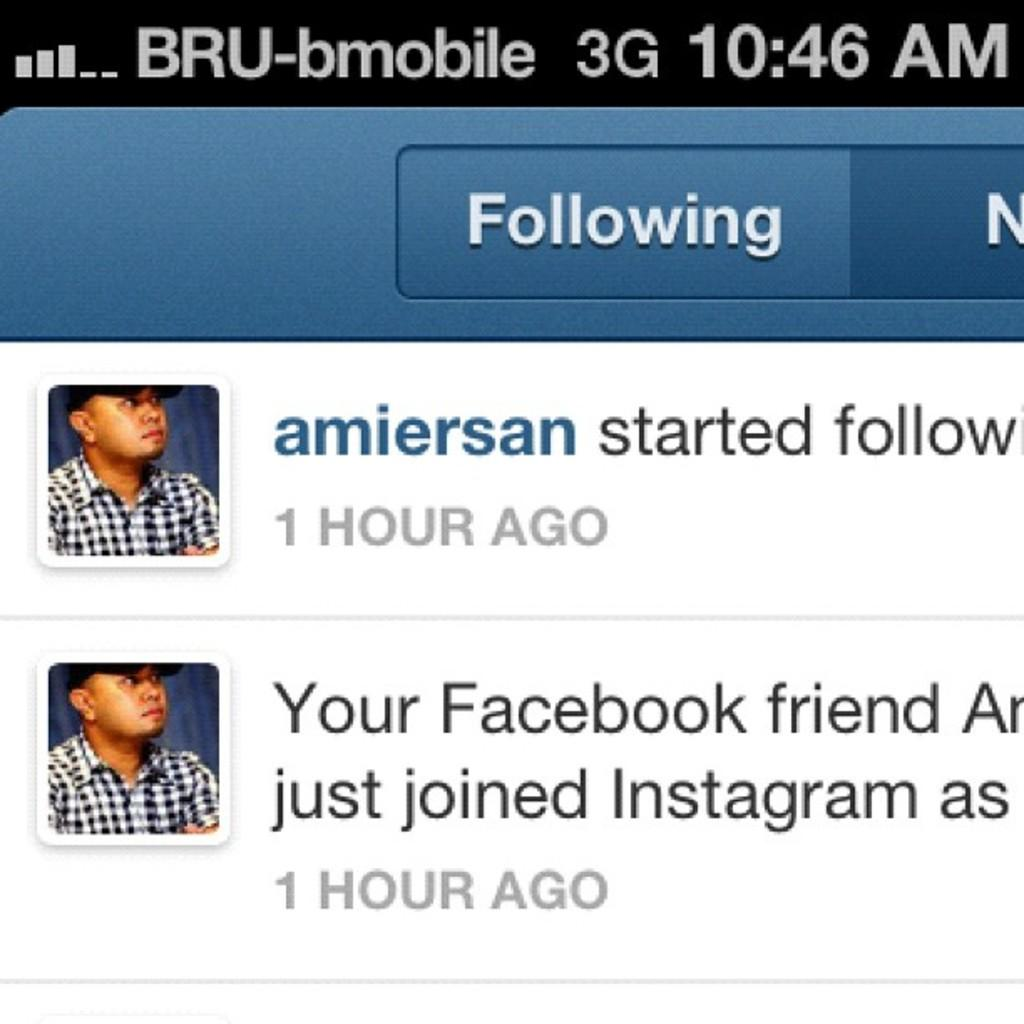What is the main subject of the image? The main subject of the image is a mobile screen. What can be seen on the mobile screen? The mobile screen displays text and person images. What type of hook can be seen hanging from the tub in the image? There is no hook or tub present in the image. 